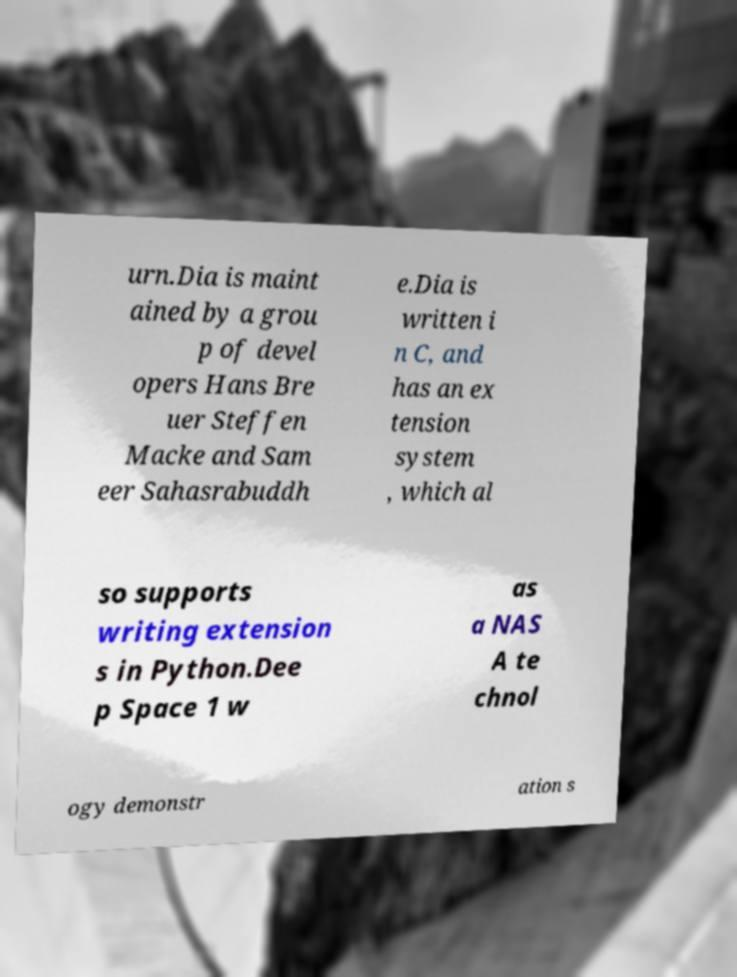Could you extract and type out the text from this image? urn.Dia is maint ained by a grou p of devel opers Hans Bre uer Steffen Macke and Sam eer Sahasrabuddh e.Dia is written i n C, and has an ex tension system , which al so supports writing extension s in Python.Dee p Space 1 w as a NAS A te chnol ogy demonstr ation s 